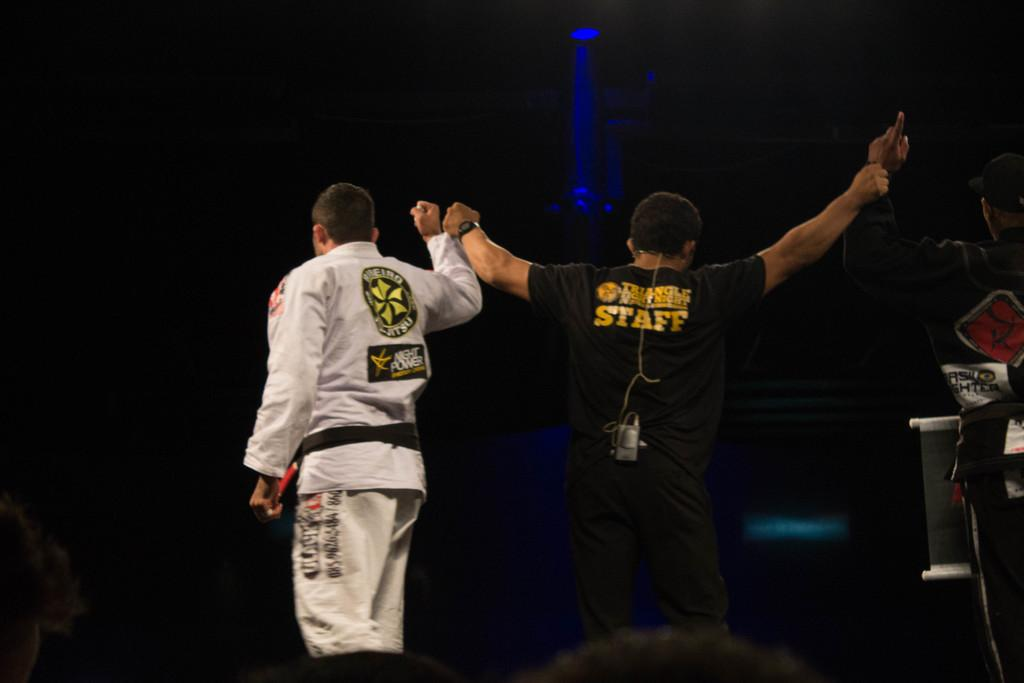<image>
Write a terse but informative summary of the picture. A member of the Triangle Fight Night staff is standing nect to one of the fighters. 